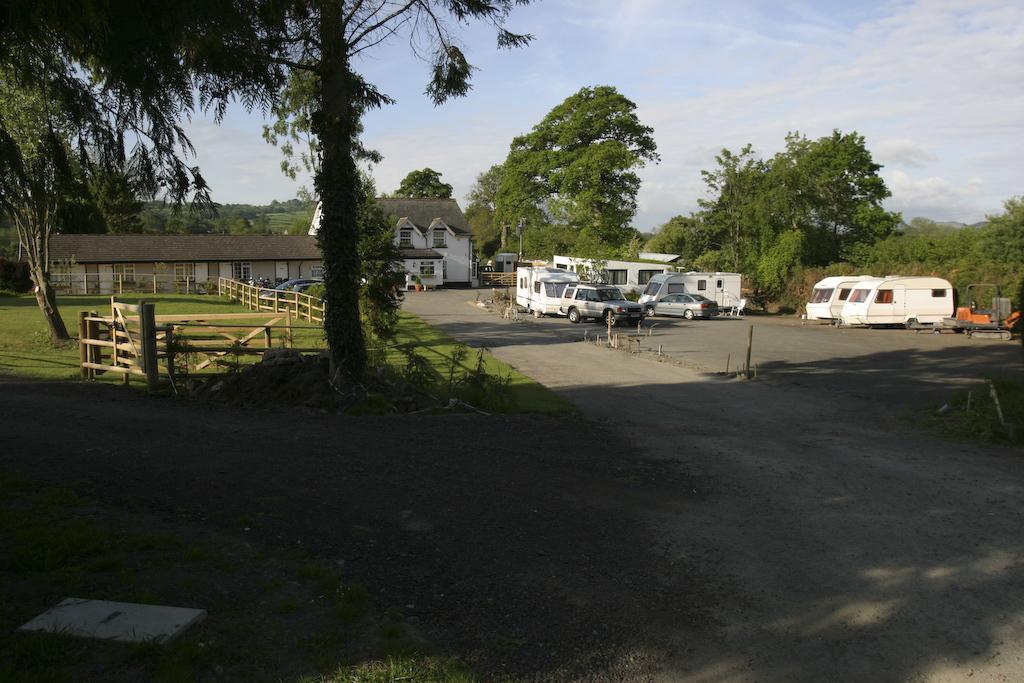Please provide a concise description of this image. In the image i can see a building with windows,trees,cars,sticks,grass,road. 